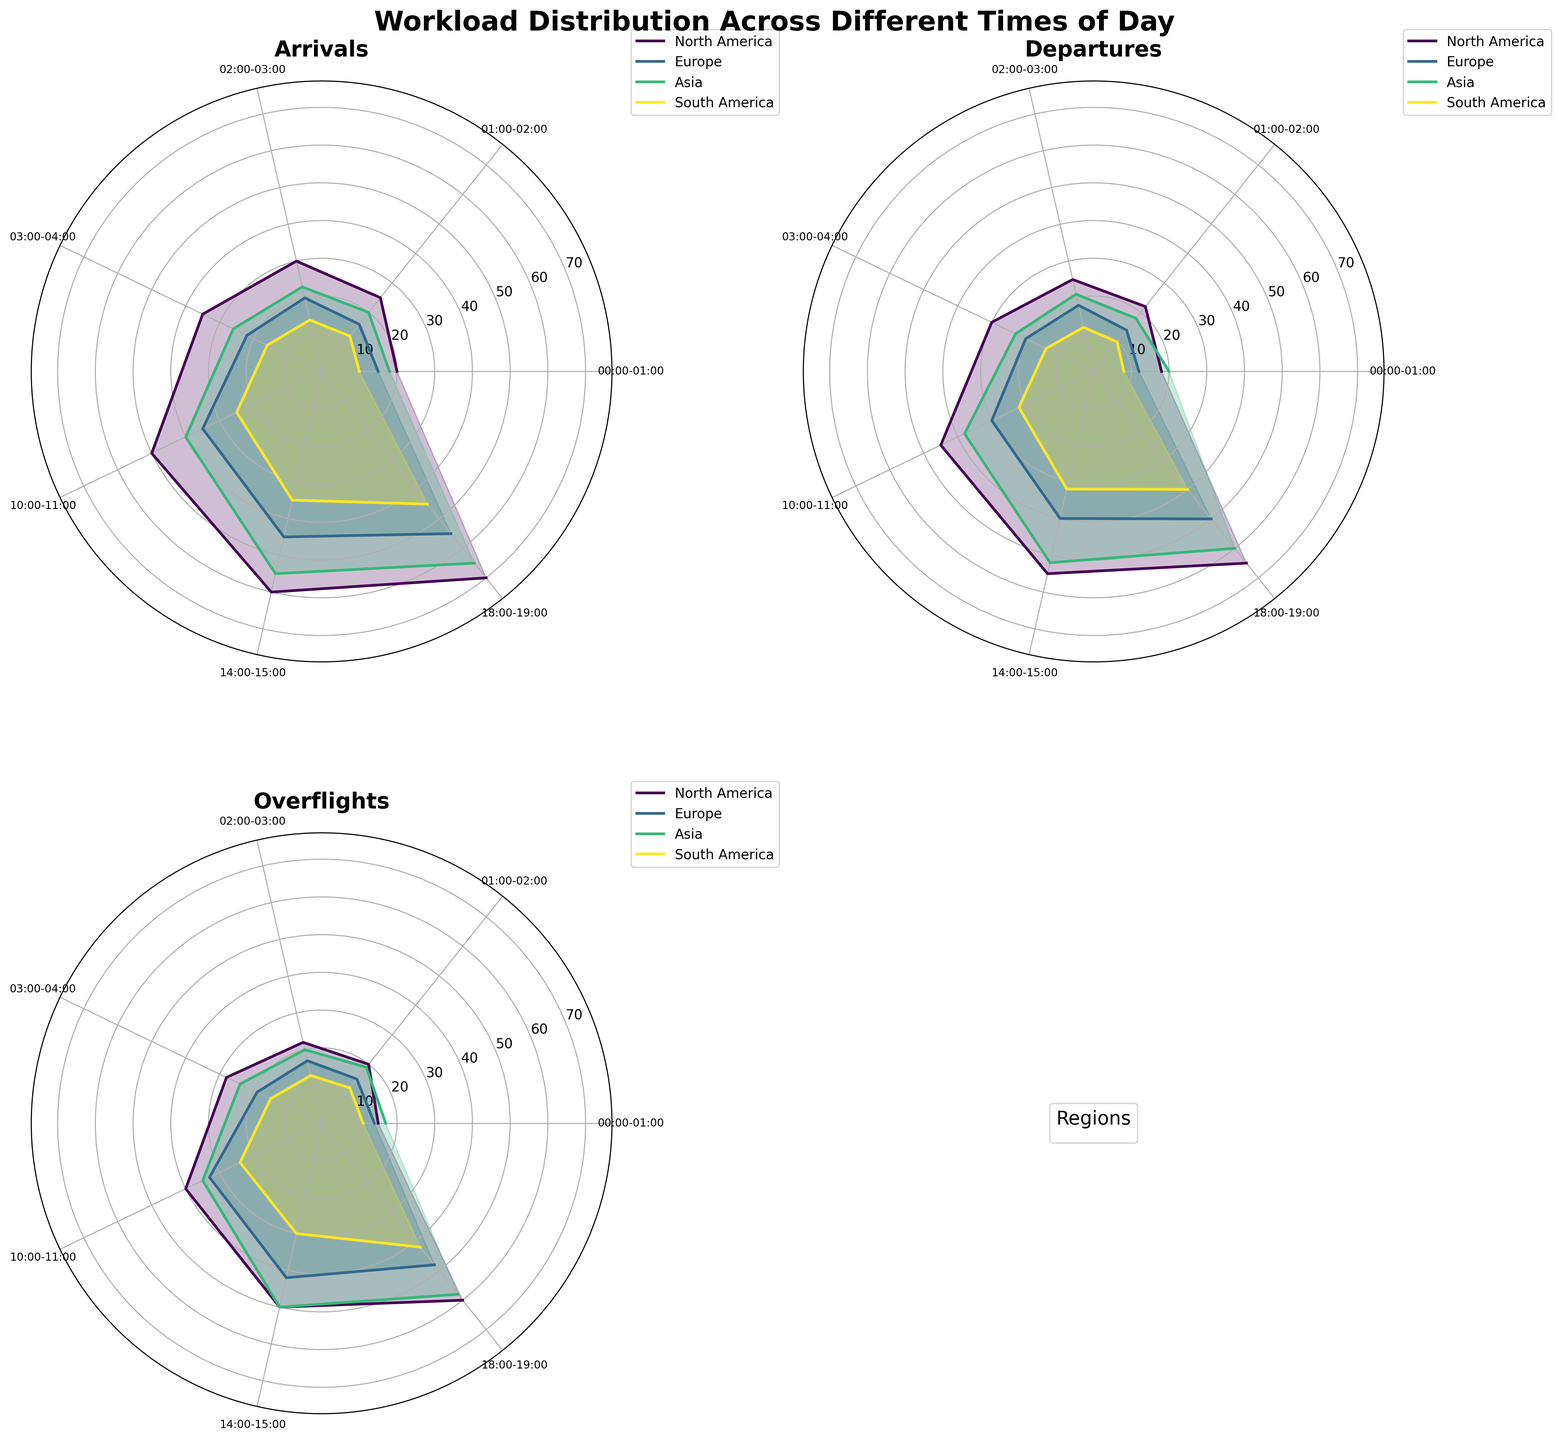What's the title of the figure? The title is usually positioned at the top of the figure, and it helps in understanding the overall topic of the visualization.
Answer: Workload Distribution Across Different Times of Day How many regions are represented in the plots? By looking at the legend or reviewing the different colored lines, we can count the number of unique regions displayed.
Answer: 4 Which region has the highest average arrivals between 18:00-19:00? By examining the arrivals subplot for the time 18:00-19:00, identify which line reaches the highest value.
Answer: North America At what time does Asia have the highest average overflights? Check the overflights subplot for the specific region (Asia) and look for the peak value in the time axis.
Answer: 14:00-15:00 Compare the average departures in Europe at 02:00-03:00 vs. 14:00-15:00. Which is higher? Locate the departure subplot and compare the values for Europe at the specified times to see which is greater.
Answer: 14:00-15:00 Are average departures or overflights generally higher for North America at 03:00-04:00? Compare the height of the lines for North America in the departures and overflights subplots at the 03:00-04:00 time slot to determine which is higher.
Answer: Departures What is the average number of departures for South America at 14:00-15:00? Look at the departures subplot and find the corresponding value for South America at 14:00-15:00.
Answer: 32 During which time period does Europe have its lowest average arrivals? Inspect the arrivals subplot for Europe and identify the time period where the value is minimum.
Answer: 00:00-01:00 Which region has a lower average number of arrivals at 01:00-02:00: South America or Europe? Compare the values in the arrivals subplot for both South America and Europe at 01:00-02:00.
Answer: South America What is the average number of overflights for North America at the peak time period? Identify the peak time period for North America in the overflights subplot and then note the corresponding value.
Answer: 60 